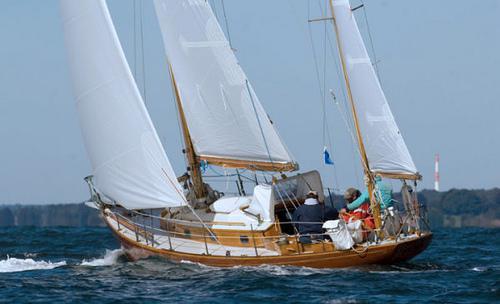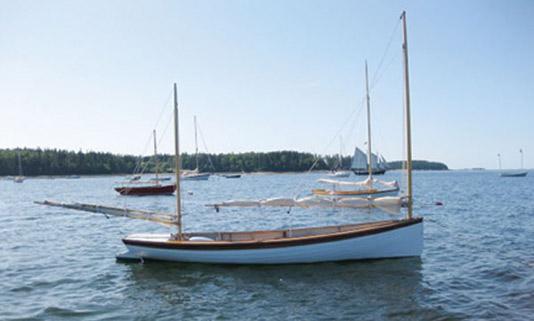The first image is the image on the left, the second image is the image on the right. Analyze the images presented: Is the assertion "There are multiple boats sailing in the left image." valid? Answer yes or no. No. 